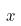<formula> <loc_0><loc_0><loc_500><loc_500>x</formula> 